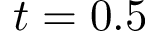Convert formula to latex. <formula><loc_0><loc_0><loc_500><loc_500>t = 0 . 5</formula> 